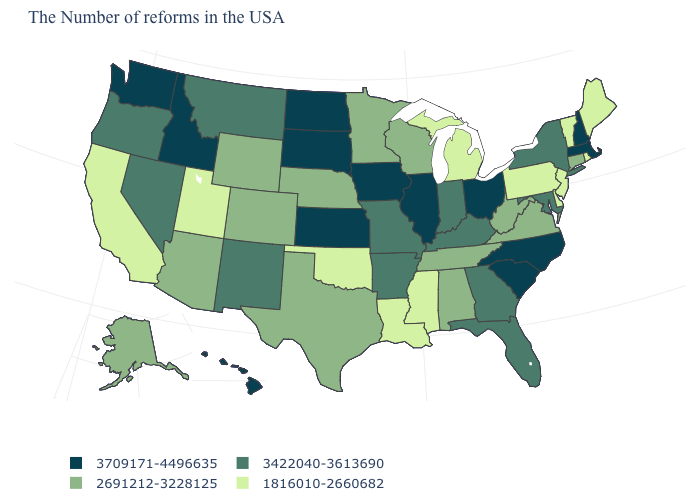Does North Carolina have the highest value in the South?
Short answer required. Yes. What is the value of Delaware?
Short answer required. 1816010-2660682. What is the value of Arizona?
Answer briefly. 2691212-3228125. What is the highest value in the USA?
Be succinct. 3709171-4496635. What is the value of Georgia?
Keep it brief. 3422040-3613690. Which states have the lowest value in the Northeast?
Quick response, please. Maine, Rhode Island, Vermont, New Jersey, Pennsylvania. Name the states that have a value in the range 1816010-2660682?
Quick response, please. Maine, Rhode Island, Vermont, New Jersey, Delaware, Pennsylvania, Michigan, Mississippi, Louisiana, Oklahoma, Utah, California. Does the map have missing data?
Quick response, please. No. What is the value of Wisconsin?
Keep it brief. 2691212-3228125. What is the value of Kansas?
Give a very brief answer. 3709171-4496635. What is the highest value in the MidWest ?
Quick response, please. 3709171-4496635. How many symbols are there in the legend?
Keep it brief. 4. Does South Carolina have the same value as North Dakota?
Short answer required. Yes. What is the value of California?
Be succinct. 1816010-2660682. What is the highest value in the USA?
Answer briefly. 3709171-4496635. 